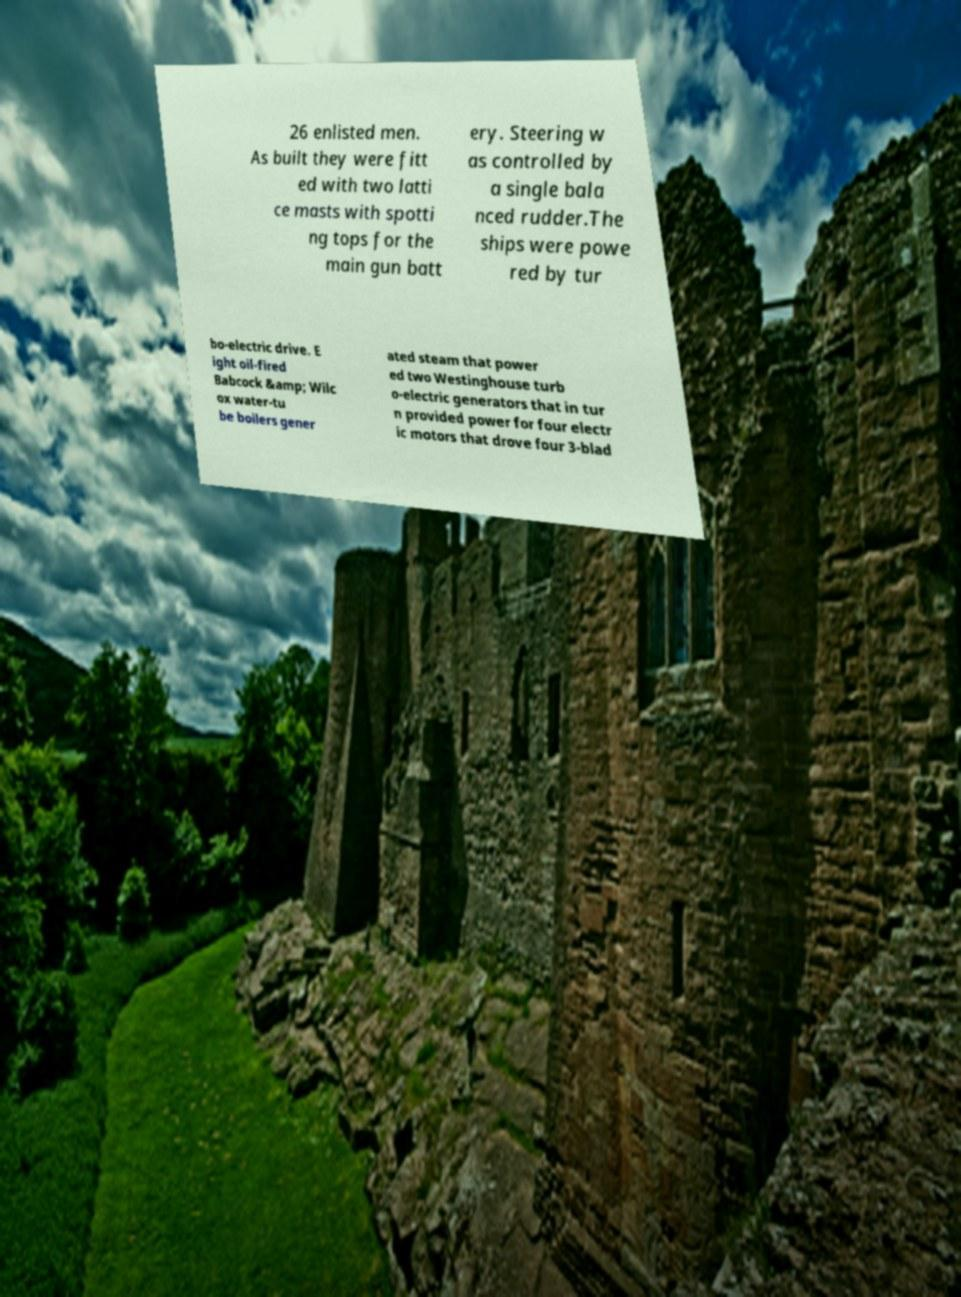What messages or text are displayed in this image? I need them in a readable, typed format. 26 enlisted men. As built they were fitt ed with two latti ce masts with spotti ng tops for the main gun batt ery. Steering w as controlled by a single bala nced rudder.The ships were powe red by tur bo-electric drive. E ight oil-fired Babcock &amp; Wilc ox water-tu be boilers gener ated steam that power ed two Westinghouse turb o-electric generators that in tur n provided power for four electr ic motors that drove four 3-blad 